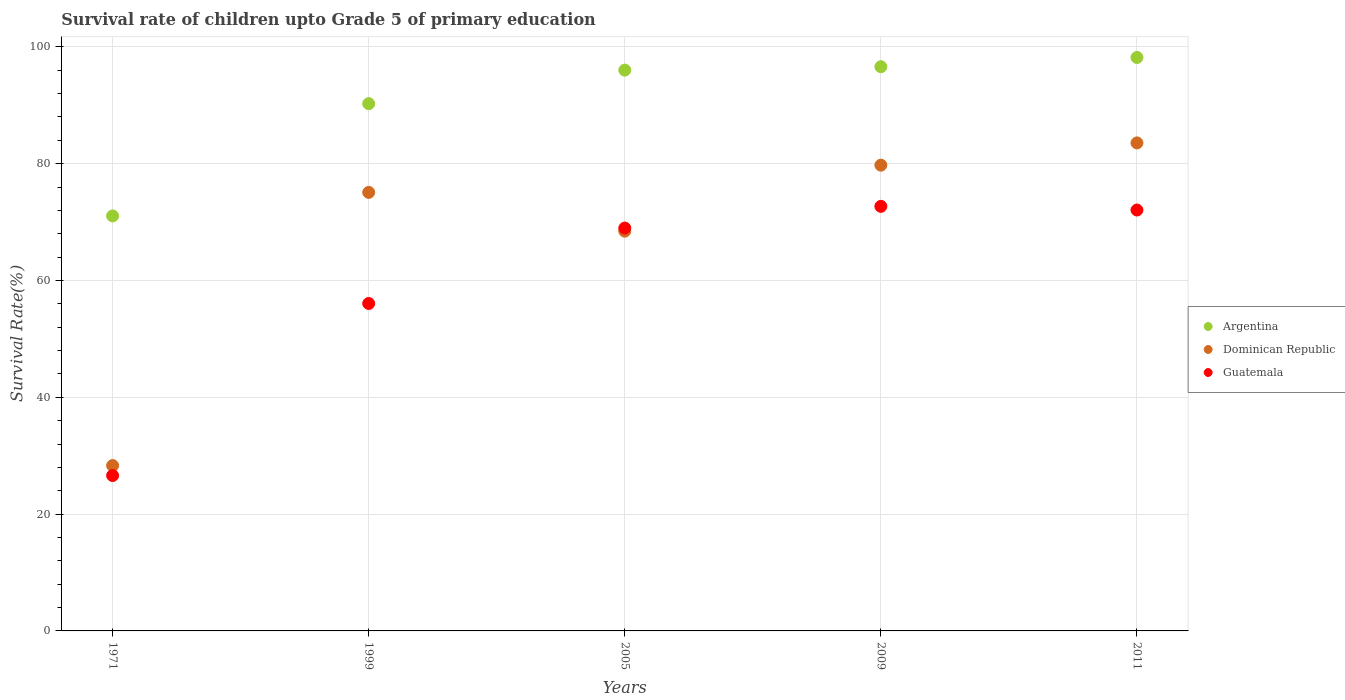How many different coloured dotlines are there?
Provide a short and direct response. 3. Is the number of dotlines equal to the number of legend labels?
Your answer should be compact. Yes. What is the survival rate of children in Argentina in 1971?
Make the answer very short. 71.06. Across all years, what is the maximum survival rate of children in Dominican Republic?
Offer a terse response. 83.56. Across all years, what is the minimum survival rate of children in Guatemala?
Offer a very short reply. 26.61. In which year was the survival rate of children in Argentina maximum?
Keep it short and to the point. 2011. In which year was the survival rate of children in Guatemala minimum?
Offer a terse response. 1971. What is the total survival rate of children in Guatemala in the graph?
Provide a short and direct response. 296.42. What is the difference between the survival rate of children in Guatemala in 2005 and that in 2009?
Offer a terse response. -3.72. What is the difference between the survival rate of children in Argentina in 1999 and the survival rate of children in Guatemala in 2005?
Make the answer very short. 21.3. What is the average survival rate of children in Dominican Republic per year?
Provide a short and direct response. 67.03. In the year 2009, what is the difference between the survival rate of children in Dominican Republic and survival rate of children in Argentina?
Your answer should be compact. -16.86. What is the ratio of the survival rate of children in Guatemala in 2009 to that in 2011?
Provide a short and direct response. 1.01. Is the survival rate of children in Dominican Republic in 1971 less than that in 1999?
Your answer should be very brief. Yes. Is the difference between the survival rate of children in Dominican Republic in 2009 and 2011 greater than the difference between the survival rate of children in Argentina in 2009 and 2011?
Keep it short and to the point. No. What is the difference between the highest and the second highest survival rate of children in Guatemala?
Provide a short and direct response. 0.63. What is the difference between the highest and the lowest survival rate of children in Argentina?
Ensure brevity in your answer.  27.13. In how many years, is the survival rate of children in Guatemala greater than the average survival rate of children in Guatemala taken over all years?
Offer a terse response. 3. Is the sum of the survival rate of children in Guatemala in 1999 and 2005 greater than the maximum survival rate of children in Dominican Republic across all years?
Your answer should be compact. Yes. Is it the case that in every year, the sum of the survival rate of children in Argentina and survival rate of children in Dominican Republic  is greater than the survival rate of children in Guatemala?
Offer a very short reply. Yes. Does the survival rate of children in Argentina monotonically increase over the years?
Provide a succinct answer. Yes. Is the survival rate of children in Guatemala strictly greater than the survival rate of children in Dominican Republic over the years?
Give a very brief answer. No. Is the survival rate of children in Argentina strictly less than the survival rate of children in Dominican Republic over the years?
Give a very brief answer. No. How many dotlines are there?
Your answer should be very brief. 3. What is the difference between two consecutive major ticks on the Y-axis?
Ensure brevity in your answer.  20. Where does the legend appear in the graph?
Offer a terse response. Center right. How are the legend labels stacked?
Ensure brevity in your answer.  Vertical. What is the title of the graph?
Provide a short and direct response. Survival rate of children upto Grade 5 of primary education. Does "Iceland" appear as one of the legend labels in the graph?
Offer a very short reply. No. What is the label or title of the X-axis?
Keep it short and to the point. Years. What is the label or title of the Y-axis?
Offer a terse response. Survival Rate(%). What is the Survival Rate(%) of Argentina in 1971?
Offer a very short reply. 71.06. What is the Survival Rate(%) in Dominican Republic in 1971?
Provide a succinct answer. 28.31. What is the Survival Rate(%) in Guatemala in 1971?
Make the answer very short. 26.61. What is the Survival Rate(%) in Argentina in 1999?
Your response must be concise. 90.28. What is the Survival Rate(%) in Dominican Republic in 1999?
Your answer should be very brief. 75.09. What is the Survival Rate(%) in Guatemala in 1999?
Your response must be concise. 56.07. What is the Survival Rate(%) in Argentina in 2005?
Your answer should be very brief. 96.03. What is the Survival Rate(%) of Dominican Republic in 2005?
Provide a short and direct response. 68.45. What is the Survival Rate(%) in Guatemala in 2005?
Keep it short and to the point. 68.98. What is the Survival Rate(%) in Argentina in 2009?
Your answer should be compact. 96.61. What is the Survival Rate(%) in Dominican Republic in 2009?
Your answer should be compact. 79.75. What is the Survival Rate(%) of Guatemala in 2009?
Your answer should be very brief. 72.7. What is the Survival Rate(%) in Argentina in 2011?
Provide a short and direct response. 98.19. What is the Survival Rate(%) in Dominican Republic in 2011?
Your answer should be compact. 83.56. What is the Survival Rate(%) in Guatemala in 2011?
Your response must be concise. 72.07. Across all years, what is the maximum Survival Rate(%) of Argentina?
Your response must be concise. 98.19. Across all years, what is the maximum Survival Rate(%) in Dominican Republic?
Ensure brevity in your answer.  83.56. Across all years, what is the maximum Survival Rate(%) of Guatemala?
Offer a terse response. 72.7. Across all years, what is the minimum Survival Rate(%) of Argentina?
Offer a terse response. 71.06. Across all years, what is the minimum Survival Rate(%) of Dominican Republic?
Ensure brevity in your answer.  28.31. Across all years, what is the minimum Survival Rate(%) in Guatemala?
Keep it short and to the point. 26.61. What is the total Survival Rate(%) in Argentina in the graph?
Keep it short and to the point. 452.18. What is the total Survival Rate(%) in Dominican Republic in the graph?
Your response must be concise. 335.17. What is the total Survival Rate(%) in Guatemala in the graph?
Make the answer very short. 296.42. What is the difference between the Survival Rate(%) in Argentina in 1971 and that in 1999?
Provide a succinct answer. -19.22. What is the difference between the Survival Rate(%) in Dominican Republic in 1971 and that in 1999?
Provide a succinct answer. -46.78. What is the difference between the Survival Rate(%) of Guatemala in 1971 and that in 1999?
Provide a short and direct response. -29.46. What is the difference between the Survival Rate(%) in Argentina in 1971 and that in 2005?
Give a very brief answer. -24.97. What is the difference between the Survival Rate(%) of Dominican Republic in 1971 and that in 2005?
Make the answer very short. -40.14. What is the difference between the Survival Rate(%) of Guatemala in 1971 and that in 2005?
Offer a terse response. -42.38. What is the difference between the Survival Rate(%) of Argentina in 1971 and that in 2009?
Ensure brevity in your answer.  -25.55. What is the difference between the Survival Rate(%) in Dominican Republic in 1971 and that in 2009?
Offer a very short reply. -51.44. What is the difference between the Survival Rate(%) in Guatemala in 1971 and that in 2009?
Provide a succinct answer. -46.09. What is the difference between the Survival Rate(%) in Argentina in 1971 and that in 2011?
Keep it short and to the point. -27.13. What is the difference between the Survival Rate(%) in Dominican Republic in 1971 and that in 2011?
Your answer should be compact. -55.25. What is the difference between the Survival Rate(%) of Guatemala in 1971 and that in 2011?
Make the answer very short. -45.46. What is the difference between the Survival Rate(%) in Argentina in 1999 and that in 2005?
Offer a terse response. -5.75. What is the difference between the Survival Rate(%) in Dominican Republic in 1999 and that in 2005?
Keep it short and to the point. 6.64. What is the difference between the Survival Rate(%) of Guatemala in 1999 and that in 2005?
Ensure brevity in your answer.  -12.92. What is the difference between the Survival Rate(%) in Argentina in 1999 and that in 2009?
Your answer should be compact. -6.33. What is the difference between the Survival Rate(%) in Dominican Republic in 1999 and that in 2009?
Provide a short and direct response. -4.66. What is the difference between the Survival Rate(%) in Guatemala in 1999 and that in 2009?
Keep it short and to the point. -16.64. What is the difference between the Survival Rate(%) in Argentina in 1999 and that in 2011?
Your answer should be compact. -7.91. What is the difference between the Survival Rate(%) of Dominican Republic in 1999 and that in 2011?
Offer a very short reply. -8.47. What is the difference between the Survival Rate(%) of Guatemala in 1999 and that in 2011?
Make the answer very short. -16. What is the difference between the Survival Rate(%) in Argentina in 2005 and that in 2009?
Provide a short and direct response. -0.58. What is the difference between the Survival Rate(%) of Dominican Republic in 2005 and that in 2009?
Your response must be concise. -11.3. What is the difference between the Survival Rate(%) of Guatemala in 2005 and that in 2009?
Offer a very short reply. -3.72. What is the difference between the Survival Rate(%) of Argentina in 2005 and that in 2011?
Make the answer very short. -2.16. What is the difference between the Survival Rate(%) of Dominican Republic in 2005 and that in 2011?
Your answer should be compact. -15.11. What is the difference between the Survival Rate(%) in Guatemala in 2005 and that in 2011?
Keep it short and to the point. -3.09. What is the difference between the Survival Rate(%) in Argentina in 2009 and that in 2011?
Your response must be concise. -1.58. What is the difference between the Survival Rate(%) of Dominican Republic in 2009 and that in 2011?
Your response must be concise. -3.81. What is the difference between the Survival Rate(%) of Guatemala in 2009 and that in 2011?
Give a very brief answer. 0.63. What is the difference between the Survival Rate(%) in Argentina in 1971 and the Survival Rate(%) in Dominican Republic in 1999?
Ensure brevity in your answer.  -4.03. What is the difference between the Survival Rate(%) in Argentina in 1971 and the Survival Rate(%) in Guatemala in 1999?
Give a very brief answer. 15. What is the difference between the Survival Rate(%) in Dominican Republic in 1971 and the Survival Rate(%) in Guatemala in 1999?
Your response must be concise. -27.75. What is the difference between the Survival Rate(%) in Argentina in 1971 and the Survival Rate(%) in Dominican Republic in 2005?
Keep it short and to the point. 2.61. What is the difference between the Survival Rate(%) in Argentina in 1971 and the Survival Rate(%) in Guatemala in 2005?
Provide a succinct answer. 2.08. What is the difference between the Survival Rate(%) of Dominican Republic in 1971 and the Survival Rate(%) of Guatemala in 2005?
Give a very brief answer. -40.67. What is the difference between the Survival Rate(%) in Argentina in 1971 and the Survival Rate(%) in Dominican Republic in 2009?
Provide a succinct answer. -8.69. What is the difference between the Survival Rate(%) of Argentina in 1971 and the Survival Rate(%) of Guatemala in 2009?
Keep it short and to the point. -1.64. What is the difference between the Survival Rate(%) of Dominican Republic in 1971 and the Survival Rate(%) of Guatemala in 2009?
Give a very brief answer. -44.39. What is the difference between the Survival Rate(%) of Argentina in 1971 and the Survival Rate(%) of Dominican Republic in 2011?
Provide a short and direct response. -12.5. What is the difference between the Survival Rate(%) in Argentina in 1971 and the Survival Rate(%) in Guatemala in 2011?
Keep it short and to the point. -1.01. What is the difference between the Survival Rate(%) in Dominican Republic in 1971 and the Survival Rate(%) in Guatemala in 2011?
Your answer should be compact. -43.76. What is the difference between the Survival Rate(%) of Argentina in 1999 and the Survival Rate(%) of Dominican Republic in 2005?
Provide a succinct answer. 21.83. What is the difference between the Survival Rate(%) of Argentina in 1999 and the Survival Rate(%) of Guatemala in 2005?
Provide a short and direct response. 21.3. What is the difference between the Survival Rate(%) of Dominican Republic in 1999 and the Survival Rate(%) of Guatemala in 2005?
Offer a terse response. 6.11. What is the difference between the Survival Rate(%) of Argentina in 1999 and the Survival Rate(%) of Dominican Republic in 2009?
Give a very brief answer. 10.53. What is the difference between the Survival Rate(%) in Argentina in 1999 and the Survival Rate(%) in Guatemala in 2009?
Ensure brevity in your answer.  17.58. What is the difference between the Survival Rate(%) of Dominican Republic in 1999 and the Survival Rate(%) of Guatemala in 2009?
Give a very brief answer. 2.39. What is the difference between the Survival Rate(%) in Argentina in 1999 and the Survival Rate(%) in Dominican Republic in 2011?
Provide a short and direct response. 6.72. What is the difference between the Survival Rate(%) of Argentina in 1999 and the Survival Rate(%) of Guatemala in 2011?
Your response must be concise. 18.21. What is the difference between the Survival Rate(%) in Dominican Republic in 1999 and the Survival Rate(%) in Guatemala in 2011?
Keep it short and to the point. 3.02. What is the difference between the Survival Rate(%) of Argentina in 2005 and the Survival Rate(%) of Dominican Republic in 2009?
Provide a short and direct response. 16.28. What is the difference between the Survival Rate(%) of Argentina in 2005 and the Survival Rate(%) of Guatemala in 2009?
Offer a terse response. 23.33. What is the difference between the Survival Rate(%) of Dominican Republic in 2005 and the Survival Rate(%) of Guatemala in 2009?
Offer a very short reply. -4.25. What is the difference between the Survival Rate(%) in Argentina in 2005 and the Survival Rate(%) in Dominican Republic in 2011?
Offer a very short reply. 12.47. What is the difference between the Survival Rate(%) of Argentina in 2005 and the Survival Rate(%) of Guatemala in 2011?
Your answer should be very brief. 23.96. What is the difference between the Survival Rate(%) in Dominican Republic in 2005 and the Survival Rate(%) in Guatemala in 2011?
Your response must be concise. -3.62. What is the difference between the Survival Rate(%) in Argentina in 2009 and the Survival Rate(%) in Dominican Republic in 2011?
Offer a terse response. 13.05. What is the difference between the Survival Rate(%) of Argentina in 2009 and the Survival Rate(%) of Guatemala in 2011?
Make the answer very short. 24.54. What is the difference between the Survival Rate(%) of Dominican Republic in 2009 and the Survival Rate(%) of Guatemala in 2011?
Offer a terse response. 7.68. What is the average Survival Rate(%) in Argentina per year?
Your answer should be compact. 90.44. What is the average Survival Rate(%) of Dominican Republic per year?
Provide a short and direct response. 67.03. What is the average Survival Rate(%) in Guatemala per year?
Your answer should be very brief. 59.28. In the year 1971, what is the difference between the Survival Rate(%) in Argentina and Survival Rate(%) in Dominican Republic?
Ensure brevity in your answer.  42.75. In the year 1971, what is the difference between the Survival Rate(%) of Argentina and Survival Rate(%) of Guatemala?
Give a very brief answer. 44.46. In the year 1971, what is the difference between the Survival Rate(%) in Dominican Republic and Survival Rate(%) in Guatemala?
Give a very brief answer. 1.71. In the year 1999, what is the difference between the Survival Rate(%) of Argentina and Survival Rate(%) of Dominican Republic?
Your response must be concise. 15.19. In the year 1999, what is the difference between the Survival Rate(%) in Argentina and Survival Rate(%) in Guatemala?
Your answer should be compact. 34.22. In the year 1999, what is the difference between the Survival Rate(%) in Dominican Republic and Survival Rate(%) in Guatemala?
Offer a very short reply. 19.03. In the year 2005, what is the difference between the Survival Rate(%) of Argentina and Survival Rate(%) of Dominican Republic?
Provide a short and direct response. 27.58. In the year 2005, what is the difference between the Survival Rate(%) in Argentina and Survival Rate(%) in Guatemala?
Give a very brief answer. 27.05. In the year 2005, what is the difference between the Survival Rate(%) in Dominican Republic and Survival Rate(%) in Guatemala?
Make the answer very short. -0.53. In the year 2009, what is the difference between the Survival Rate(%) of Argentina and Survival Rate(%) of Dominican Republic?
Ensure brevity in your answer.  16.86. In the year 2009, what is the difference between the Survival Rate(%) of Argentina and Survival Rate(%) of Guatemala?
Provide a short and direct response. 23.91. In the year 2009, what is the difference between the Survival Rate(%) of Dominican Republic and Survival Rate(%) of Guatemala?
Give a very brief answer. 7.05. In the year 2011, what is the difference between the Survival Rate(%) of Argentina and Survival Rate(%) of Dominican Republic?
Your response must be concise. 14.63. In the year 2011, what is the difference between the Survival Rate(%) in Argentina and Survival Rate(%) in Guatemala?
Offer a very short reply. 26.12. In the year 2011, what is the difference between the Survival Rate(%) of Dominican Republic and Survival Rate(%) of Guatemala?
Offer a very short reply. 11.49. What is the ratio of the Survival Rate(%) of Argentina in 1971 to that in 1999?
Provide a succinct answer. 0.79. What is the ratio of the Survival Rate(%) of Dominican Republic in 1971 to that in 1999?
Offer a very short reply. 0.38. What is the ratio of the Survival Rate(%) in Guatemala in 1971 to that in 1999?
Your answer should be very brief. 0.47. What is the ratio of the Survival Rate(%) in Argentina in 1971 to that in 2005?
Offer a very short reply. 0.74. What is the ratio of the Survival Rate(%) of Dominican Republic in 1971 to that in 2005?
Give a very brief answer. 0.41. What is the ratio of the Survival Rate(%) in Guatemala in 1971 to that in 2005?
Give a very brief answer. 0.39. What is the ratio of the Survival Rate(%) of Argentina in 1971 to that in 2009?
Your answer should be compact. 0.74. What is the ratio of the Survival Rate(%) of Dominican Republic in 1971 to that in 2009?
Give a very brief answer. 0.35. What is the ratio of the Survival Rate(%) in Guatemala in 1971 to that in 2009?
Give a very brief answer. 0.37. What is the ratio of the Survival Rate(%) of Argentina in 1971 to that in 2011?
Keep it short and to the point. 0.72. What is the ratio of the Survival Rate(%) in Dominican Republic in 1971 to that in 2011?
Your answer should be very brief. 0.34. What is the ratio of the Survival Rate(%) of Guatemala in 1971 to that in 2011?
Ensure brevity in your answer.  0.37. What is the ratio of the Survival Rate(%) of Argentina in 1999 to that in 2005?
Provide a short and direct response. 0.94. What is the ratio of the Survival Rate(%) of Dominican Republic in 1999 to that in 2005?
Offer a terse response. 1.1. What is the ratio of the Survival Rate(%) of Guatemala in 1999 to that in 2005?
Ensure brevity in your answer.  0.81. What is the ratio of the Survival Rate(%) of Argentina in 1999 to that in 2009?
Make the answer very short. 0.93. What is the ratio of the Survival Rate(%) in Dominican Republic in 1999 to that in 2009?
Provide a short and direct response. 0.94. What is the ratio of the Survival Rate(%) of Guatemala in 1999 to that in 2009?
Offer a very short reply. 0.77. What is the ratio of the Survival Rate(%) in Argentina in 1999 to that in 2011?
Give a very brief answer. 0.92. What is the ratio of the Survival Rate(%) of Dominican Republic in 1999 to that in 2011?
Ensure brevity in your answer.  0.9. What is the ratio of the Survival Rate(%) of Guatemala in 1999 to that in 2011?
Ensure brevity in your answer.  0.78. What is the ratio of the Survival Rate(%) in Argentina in 2005 to that in 2009?
Keep it short and to the point. 0.99. What is the ratio of the Survival Rate(%) of Dominican Republic in 2005 to that in 2009?
Keep it short and to the point. 0.86. What is the ratio of the Survival Rate(%) of Guatemala in 2005 to that in 2009?
Provide a succinct answer. 0.95. What is the ratio of the Survival Rate(%) of Argentina in 2005 to that in 2011?
Give a very brief answer. 0.98. What is the ratio of the Survival Rate(%) of Dominican Republic in 2005 to that in 2011?
Your answer should be very brief. 0.82. What is the ratio of the Survival Rate(%) in Guatemala in 2005 to that in 2011?
Make the answer very short. 0.96. What is the ratio of the Survival Rate(%) of Argentina in 2009 to that in 2011?
Ensure brevity in your answer.  0.98. What is the ratio of the Survival Rate(%) in Dominican Republic in 2009 to that in 2011?
Your answer should be compact. 0.95. What is the ratio of the Survival Rate(%) of Guatemala in 2009 to that in 2011?
Your answer should be very brief. 1.01. What is the difference between the highest and the second highest Survival Rate(%) of Argentina?
Provide a succinct answer. 1.58. What is the difference between the highest and the second highest Survival Rate(%) in Dominican Republic?
Make the answer very short. 3.81. What is the difference between the highest and the second highest Survival Rate(%) in Guatemala?
Give a very brief answer. 0.63. What is the difference between the highest and the lowest Survival Rate(%) in Argentina?
Provide a short and direct response. 27.13. What is the difference between the highest and the lowest Survival Rate(%) in Dominican Republic?
Give a very brief answer. 55.25. What is the difference between the highest and the lowest Survival Rate(%) in Guatemala?
Provide a short and direct response. 46.09. 